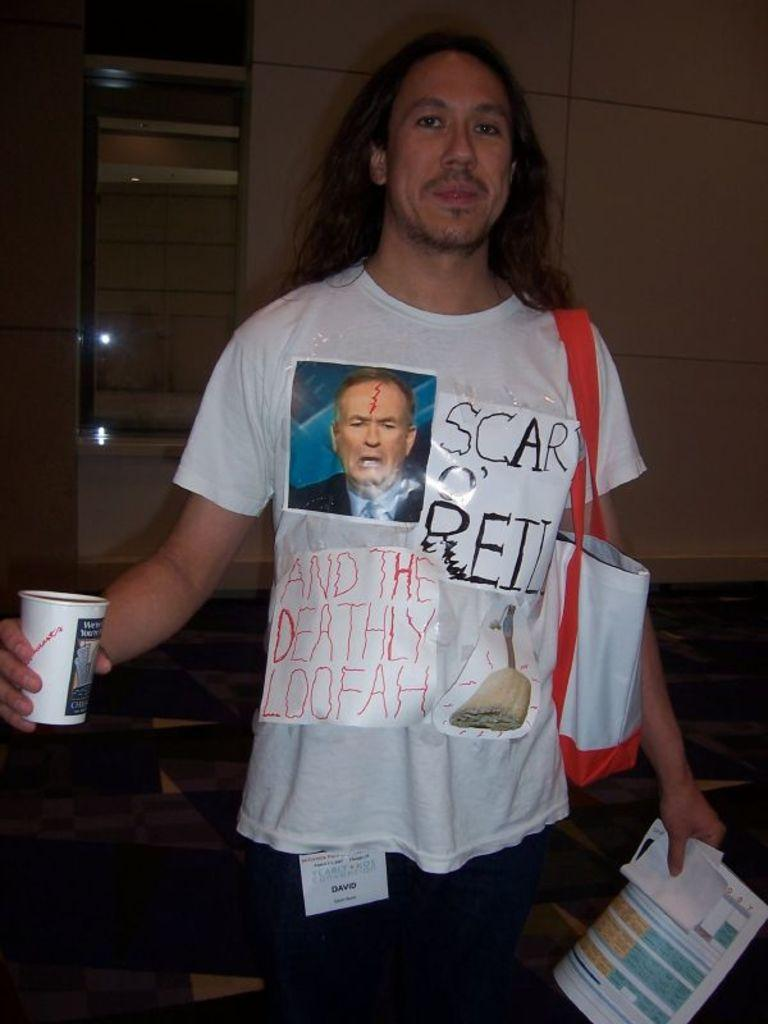<image>
Describe the image concisely. A person wears a white shirt with red text that says AND THE DEATHLY LOOFAH. 